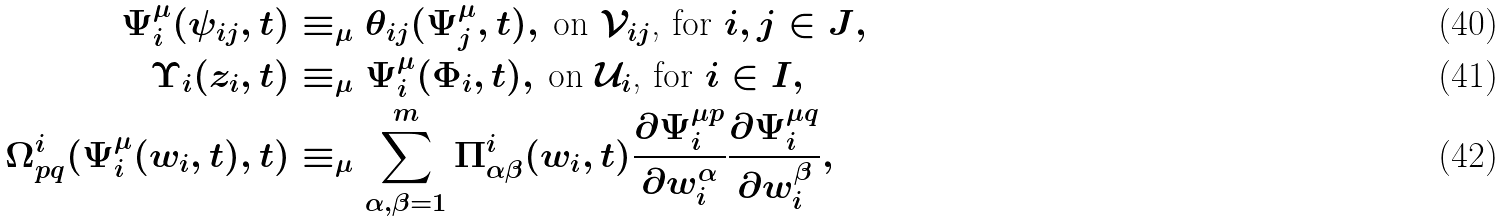Convert formula to latex. <formula><loc_0><loc_0><loc_500><loc_500>\Psi _ { i } ^ { \mu } ( \psi _ { i j } , t ) & \equiv _ { \mu } \theta _ { i j } ( \Psi _ { j } ^ { \mu } , t ) , \, \text {on $\mathcal{V}_{ij}$, for $i,j\in J$} , \\ \Upsilon _ { i } ( z _ { i } , t ) & \equiv _ { \mu } \Psi _ { i } ^ { \mu } ( \Phi _ { i } , t ) , \, \text {on $\mathcal{U}_{i}$, for $i\in I$} , \\ \Omega _ { p q } ^ { i } ( \Psi _ { i } ^ { \mu } ( w _ { i } , t ) , t ) & \equiv _ { \mu } \sum _ { \alpha , \beta = 1 } ^ { m } \Pi _ { \alpha \beta } ^ { i } ( w _ { i } , t ) \frac { \partial \Psi _ { i } ^ { \mu p } } { \partial w _ { i } ^ { \alpha } } \frac { \partial \Psi _ { i } ^ { \mu q } } { \partial w _ { i } ^ { \beta } } ,</formula> 